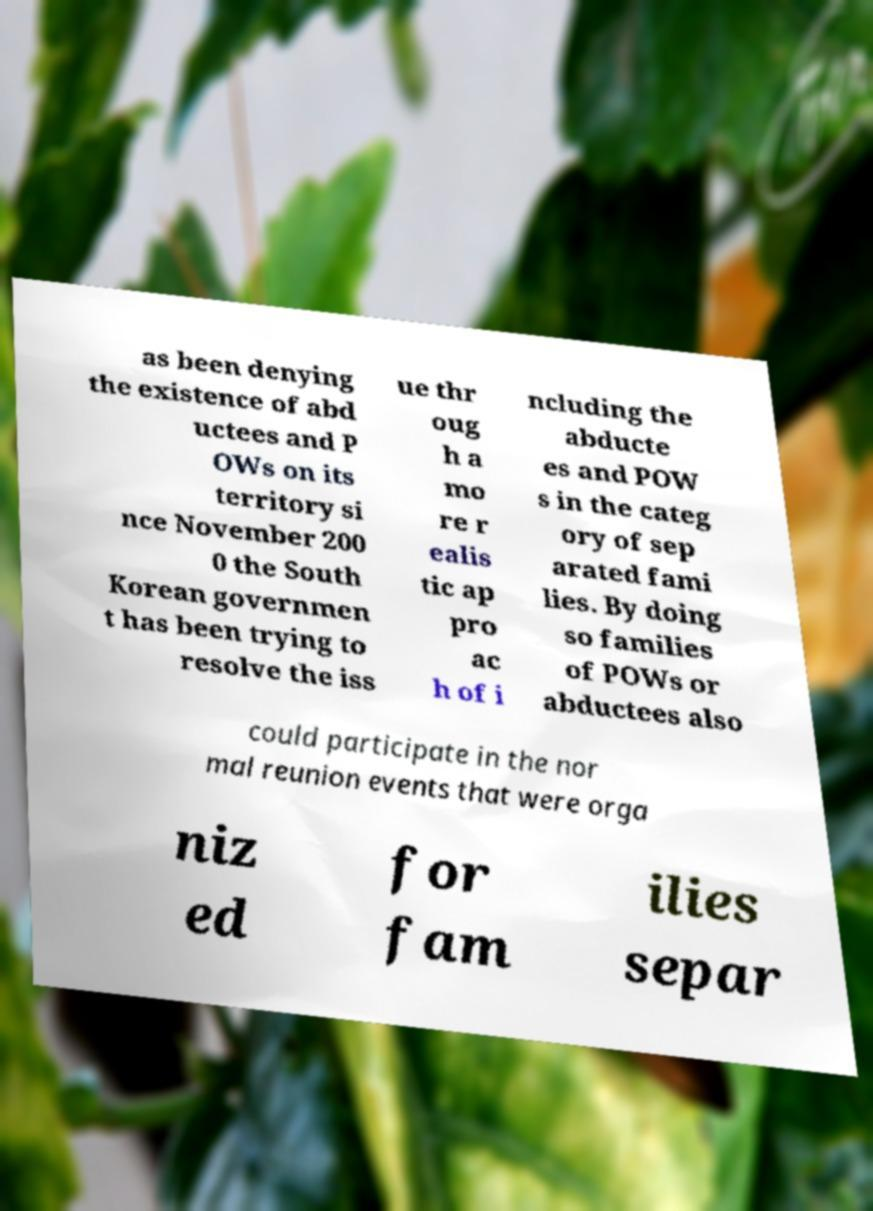Can you accurately transcribe the text from the provided image for me? as been denying the existence of abd uctees and P OWs on its territory si nce November 200 0 the South Korean governmen t has been trying to resolve the iss ue thr oug h a mo re r ealis tic ap pro ac h of i ncluding the abducte es and POW s in the categ ory of sep arated fami lies. By doing so families of POWs or abductees also could participate in the nor mal reunion events that were orga niz ed for fam ilies separ 